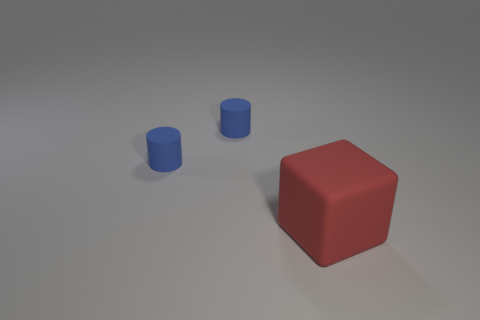What is the texture of the objects? The objects appear to have a matte texture, with no significant reflections or glossiness. The surface of the cube and the cylinders show slight variations in light, suggesting a slightly rough or diffuse surface texture that scatters the light. 